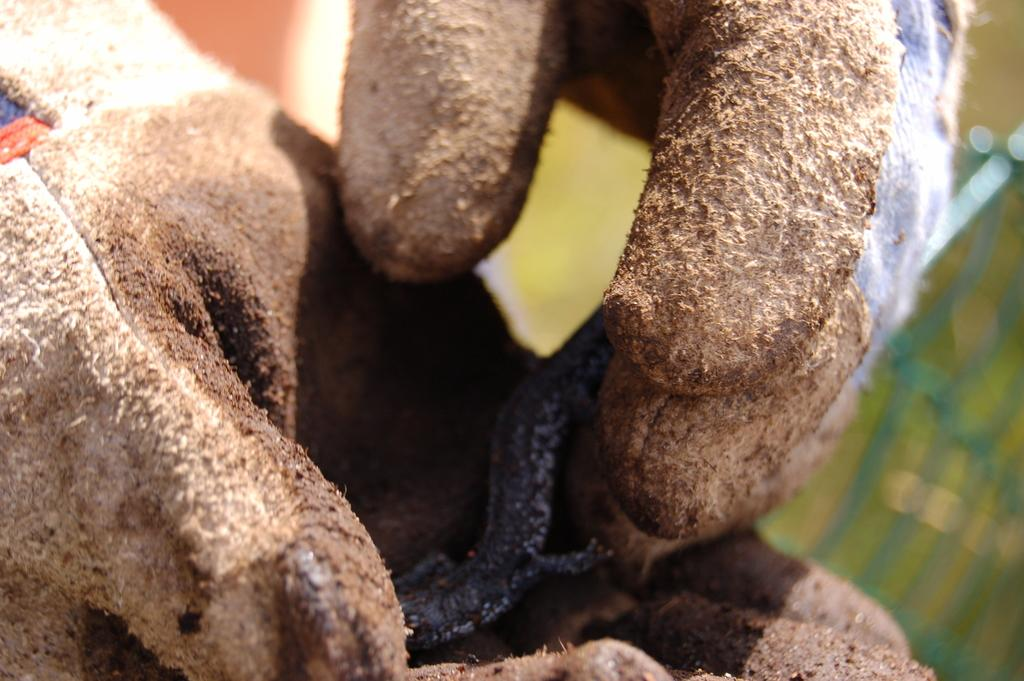What can be seen in the image? There is a person in the image. What is the person wearing on their hand? The person's hand is wearing gloves. What color are the gloves? The gloves are brown in color. What is the person holding in their hand? The person is holding a black colored object. What colors can be seen in the background of the image? The background of the image is green and orange in color. Can you see any trains through the window in the image? There is no window present in the image, so it is not possible to see any trains. 